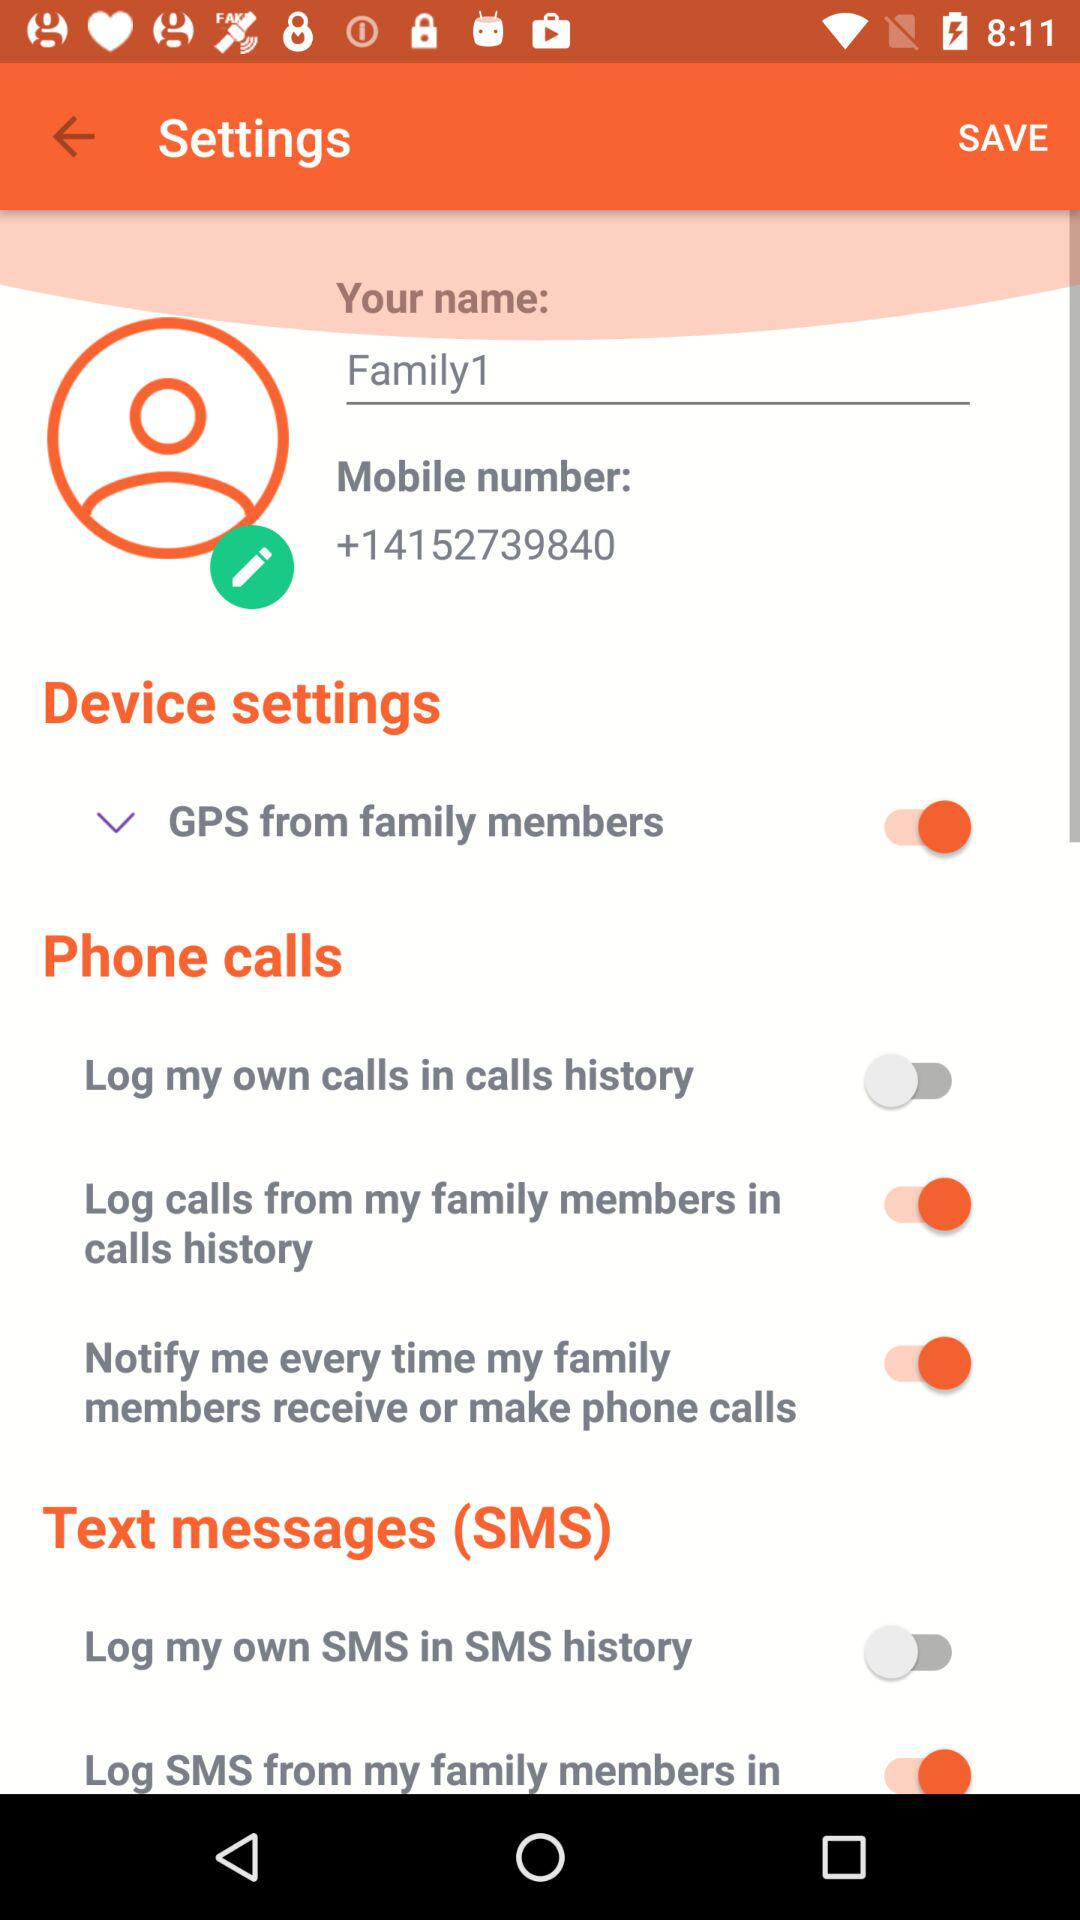What is the status of "GPS from family members"? The status of "GPS from family members" is "on". 